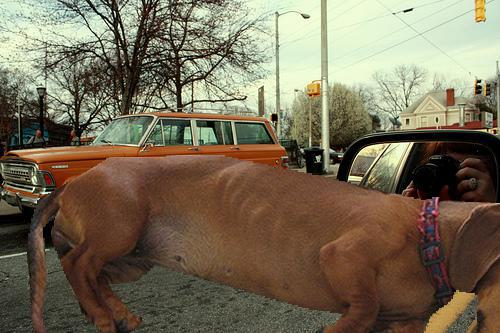What kind of vehicle is seen in the background of this image? The vehicle in the background is an orange station wagon. 